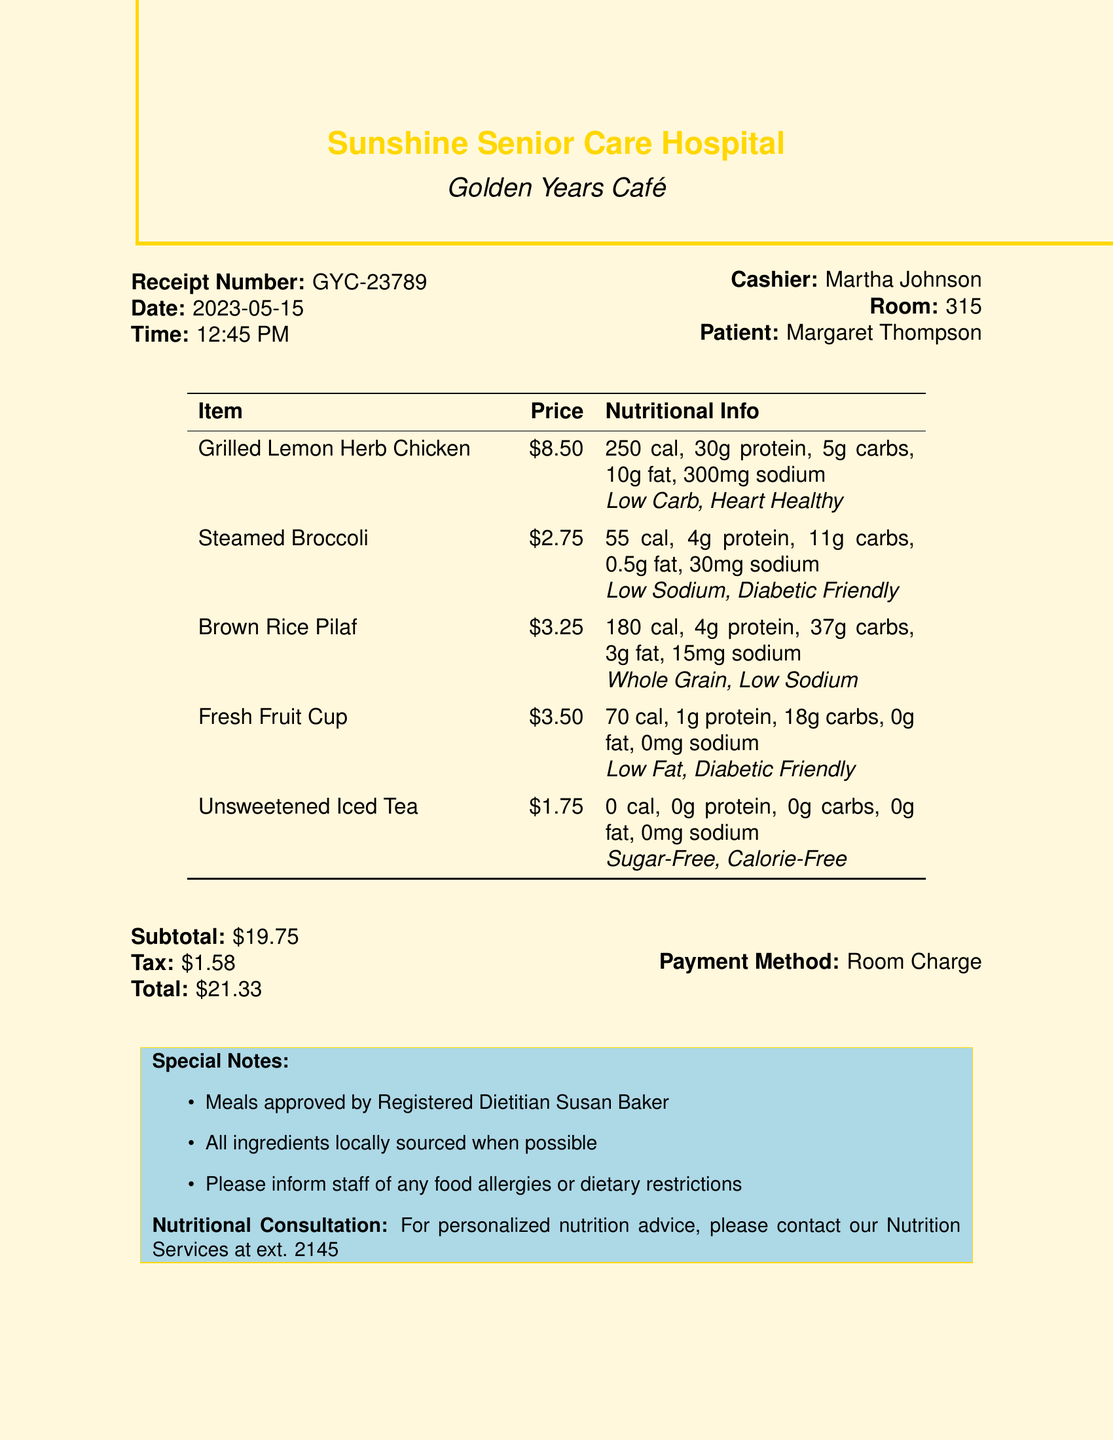What is the name of the hospital? The name of the hospital is stated at the top of the receipt.
Answer: Sunshine Senior Care Hospital Who is the cashier? The cashier's name is listed on the receipt.
Answer: Martha Johnson What is the total amount charged? The total amount is provided at the end of the receipt.
Answer: $21.33 What is the date of the meal? The date is specified prominently on the receipt.
Answer: 2023-05-15 Which item has the lowest calories? The item with the lowest calories can be found in the nutritional information section.
Answer: Unsweetened Iced Tea How many grams of protein does the Grilled Lemon Herb Chicken contain? This detail is included in the nutritional information for the respective item.
Answer: 30g What special diet is associated with the Fresh Fruit Cup? The special diet is listed alongside the item.
Answer: Low Fat, Diabetic Friendly What is the receipt number? The receipt number is clearly labeled on the document.
Answer: GYC-23789 Who approved the meals? The name of the dietitian who approved the meals is included in the special notes section.
Answer: Registered Dietitian Susan Baker 